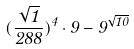Convert formula to latex. <formula><loc_0><loc_0><loc_500><loc_500>( \frac { \sqrt { 1 } } { 2 8 8 } ) ^ { 4 } \cdot 9 - 9 ^ { \sqrt { 1 0 } }</formula> 